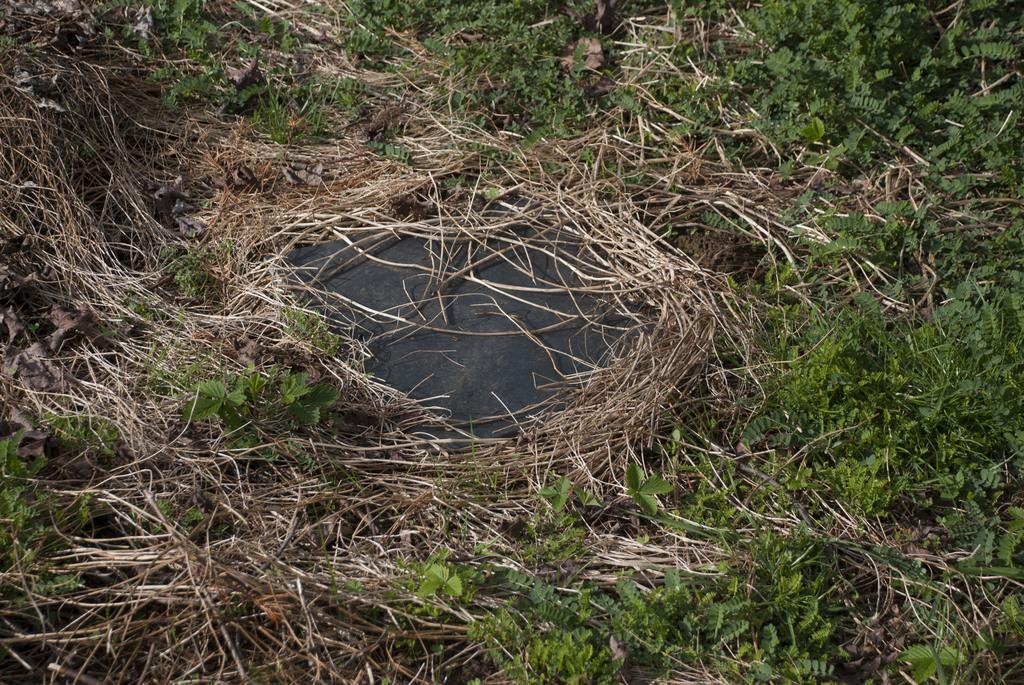What type of vegetation is present in the image? There are plants in the image. Can you describe the condition of the grass in the image? The grass in the image is dry. What type of question is being asked in the image? There is no question present in the image; it only contains plants and dry grass. Is there any poison visible in the image? There is no poison present in the image; it only contains plants and dry grass. 